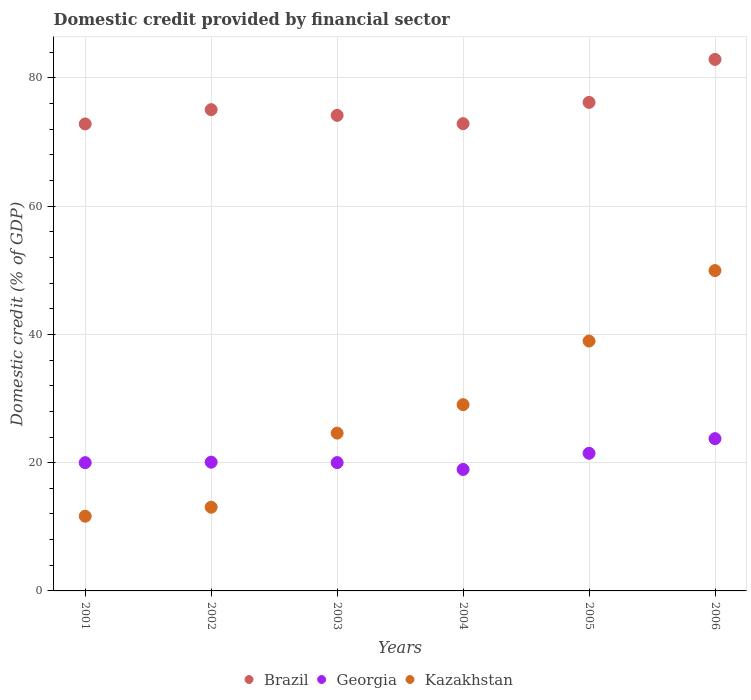How many different coloured dotlines are there?
Your answer should be compact. 3. What is the domestic credit in Georgia in 2004?
Ensure brevity in your answer.  18.95. Across all years, what is the maximum domestic credit in Kazakhstan?
Provide a succinct answer. 49.96. Across all years, what is the minimum domestic credit in Brazil?
Ensure brevity in your answer.  72.83. In which year was the domestic credit in Georgia minimum?
Make the answer very short. 2004. What is the total domestic credit in Georgia in the graph?
Give a very brief answer. 124.26. What is the difference between the domestic credit in Georgia in 2004 and that in 2005?
Offer a terse response. -2.52. What is the difference between the domestic credit in Brazil in 2003 and the domestic credit in Georgia in 2005?
Provide a short and direct response. 52.71. What is the average domestic credit in Kazakhstan per year?
Give a very brief answer. 27.88. In the year 2004, what is the difference between the domestic credit in Kazakhstan and domestic credit in Brazil?
Offer a terse response. -43.82. What is the ratio of the domestic credit in Kazakhstan in 2003 to that in 2005?
Make the answer very short. 0.63. Is the domestic credit in Georgia in 2002 less than that in 2006?
Your answer should be very brief. Yes. Is the difference between the domestic credit in Kazakhstan in 2003 and 2004 greater than the difference between the domestic credit in Brazil in 2003 and 2004?
Ensure brevity in your answer.  No. What is the difference between the highest and the second highest domestic credit in Kazakhstan?
Your response must be concise. 10.99. What is the difference between the highest and the lowest domestic credit in Kazakhstan?
Your answer should be compact. 38.31. In how many years, is the domestic credit in Brazil greater than the average domestic credit in Brazil taken over all years?
Keep it short and to the point. 2. Does the domestic credit in Georgia monotonically increase over the years?
Offer a very short reply. No. Is the domestic credit in Georgia strictly less than the domestic credit in Brazil over the years?
Provide a succinct answer. Yes. How many dotlines are there?
Your answer should be compact. 3. How many years are there in the graph?
Your answer should be compact. 6. What is the difference between two consecutive major ticks on the Y-axis?
Ensure brevity in your answer.  20. Does the graph contain any zero values?
Ensure brevity in your answer.  No. Does the graph contain grids?
Keep it short and to the point. Yes. Where does the legend appear in the graph?
Offer a terse response. Bottom center. What is the title of the graph?
Offer a very short reply. Domestic credit provided by financial sector. What is the label or title of the Y-axis?
Ensure brevity in your answer.  Domestic credit (% of GDP). What is the Domestic credit (% of GDP) of Brazil in 2001?
Provide a short and direct response. 72.83. What is the Domestic credit (% of GDP) of Georgia in 2001?
Offer a terse response. 20. What is the Domestic credit (% of GDP) of Kazakhstan in 2001?
Your response must be concise. 11.65. What is the Domestic credit (% of GDP) in Brazil in 2002?
Make the answer very short. 75.06. What is the Domestic credit (% of GDP) in Georgia in 2002?
Make the answer very short. 20.08. What is the Domestic credit (% of GDP) in Kazakhstan in 2002?
Your answer should be compact. 13.06. What is the Domestic credit (% of GDP) of Brazil in 2003?
Keep it short and to the point. 74.17. What is the Domestic credit (% of GDP) of Georgia in 2003?
Offer a very short reply. 20.02. What is the Domestic credit (% of GDP) in Kazakhstan in 2003?
Provide a short and direct response. 24.61. What is the Domestic credit (% of GDP) in Brazil in 2004?
Keep it short and to the point. 72.87. What is the Domestic credit (% of GDP) in Georgia in 2004?
Give a very brief answer. 18.95. What is the Domestic credit (% of GDP) of Kazakhstan in 2004?
Make the answer very short. 29.05. What is the Domestic credit (% of GDP) in Brazil in 2005?
Provide a short and direct response. 76.19. What is the Domestic credit (% of GDP) in Georgia in 2005?
Keep it short and to the point. 21.47. What is the Domestic credit (% of GDP) in Kazakhstan in 2005?
Provide a short and direct response. 38.97. What is the Domestic credit (% of GDP) in Brazil in 2006?
Give a very brief answer. 82.9. What is the Domestic credit (% of GDP) of Georgia in 2006?
Ensure brevity in your answer.  23.75. What is the Domestic credit (% of GDP) in Kazakhstan in 2006?
Make the answer very short. 49.96. Across all years, what is the maximum Domestic credit (% of GDP) of Brazil?
Ensure brevity in your answer.  82.9. Across all years, what is the maximum Domestic credit (% of GDP) of Georgia?
Provide a short and direct response. 23.75. Across all years, what is the maximum Domestic credit (% of GDP) in Kazakhstan?
Keep it short and to the point. 49.96. Across all years, what is the minimum Domestic credit (% of GDP) of Brazil?
Offer a very short reply. 72.83. Across all years, what is the minimum Domestic credit (% of GDP) of Georgia?
Ensure brevity in your answer.  18.95. Across all years, what is the minimum Domestic credit (% of GDP) of Kazakhstan?
Your response must be concise. 11.65. What is the total Domestic credit (% of GDP) in Brazil in the graph?
Provide a succinct answer. 454.03. What is the total Domestic credit (% of GDP) of Georgia in the graph?
Give a very brief answer. 124.26. What is the total Domestic credit (% of GDP) in Kazakhstan in the graph?
Your answer should be compact. 167.3. What is the difference between the Domestic credit (% of GDP) of Brazil in 2001 and that in 2002?
Give a very brief answer. -2.23. What is the difference between the Domestic credit (% of GDP) in Georgia in 2001 and that in 2002?
Keep it short and to the point. -0.08. What is the difference between the Domestic credit (% of GDP) of Kazakhstan in 2001 and that in 2002?
Your answer should be very brief. -1.41. What is the difference between the Domestic credit (% of GDP) of Brazil in 2001 and that in 2003?
Offer a very short reply. -1.34. What is the difference between the Domestic credit (% of GDP) of Georgia in 2001 and that in 2003?
Make the answer very short. -0.01. What is the difference between the Domestic credit (% of GDP) of Kazakhstan in 2001 and that in 2003?
Keep it short and to the point. -12.96. What is the difference between the Domestic credit (% of GDP) of Brazil in 2001 and that in 2004?
Give a very brief answer. -0.04. What is the difference between the Domestic credit (% of GDP) in Georgia in 2001 and that in 2004?
Your answer should be very brief. 1.06. What is the difference between the Domestic credit (% of GDP) of Kazakhstan in 2001 and that in 2004?
Make the answer very short. -17.4. What is the difference between the Domestic credit (% of GDP) in Brazil in 2001 and that in 2005?
Your answer should be very brief. -3.36. What is the difference between the Domestic credit (% of GDP) in Georgia in 2001 and that in 2005?
Provide a short and direct response. -1.46. What is the difference between the Domestic credit (% of GDP) of Kazakhstan in 2001 and that in 2005?
Ensure brevity in your answer.  -27.32. What is the difference between the Domestic credit (% of GDP) of Brazil in 2001 and that in 2006?
Provide a succinct answer. -10.06. What is the difference between the Domestic credit (% of GDP) of Georgia in 2001 and that in 2006?
Keep it short and to the point. -3.75. What is the difference between the Domestic credit (% of GDP) of Kazakhstan in 2001 and that in 2006?
Make the answer very short. -38.31. What is the difference between the Domestic credit (% of GDP) of Brazil in 2002 and that in 2003?
Your answer should be very brief. 0.89. What is the difference between the Domestic credit (% of GDP) of Georgia in 2002 and that in 2003?
Give a very brief answer. 0.07. What is the difference between the Domestic credit (% of GDP) of Kazakhstan in 2002 and that in 2003?
Ensure brevity in your answer.  -11.56. What is the difference between the Domestic credit (% of GDP) of Brazil in 2002 and that in 2004?
Give a very brief answer. 2.19. What is the difference between the Domestic credit (% of GDP) of Georgia in 2002 and that in 2004?
Keep it short and to the point. 1.13. What is the difference between the Domestic credit (% of GDP) in Kazakhstan in 2002 and that in 2004?
Keep it short and to the point. -16. What is the difference between the Domestic credit (% of GDP) of Brazil in 2002 and that in 2005?
Offer a very short reply. -1.13. What is the difference between the Domestic credit (% of GDP) of Georgia in 2002 and that in 2005?
Offer a terse response. -1.39. What is the difference between the Domestic credit (% of GDP) of Kazakhstan in 2002 and that in 2005?
Your answer should be compact. -25.91. What is the difference between the Domestic credit (% of GDP) in Brazil in 2002 and that in 2006?
Your answer should be compact. -7.84. What is the difference between the Domestic credit (% of GDP) of Georgia in 2002 and that in 2006?
Ensure brevity in your answer.  -3.67. What is the difference between the Domestic credit (% of GDP) of Kazakhstan in 2002 and that in 2006?
Give a very brief answer. -36.91. What is the difference between the Domestic credit (% of GDP) of Brazil in 2003 and that in 2004?
Give a very brief answer. 1.3. What is the difference between the Domestic credit (% of GDP) in Georgia in 2003 and that in 2004?
Provide a short and direct response. 1.07. What is the difference between the Domestic credit (% of GDP) in Kazakhstan in 2003 and that in 2004?
Provide a short and direct response. -4.44. What is the difference between the Domestic credit (% of GDP) in Brazil in 2003 and that in 2005?
Keep it short and to the point. -2.02. What is the difference between the Domestic credit (% of GDP) of Georgia in 2003 and that in 2005?
Provide a short and direct response. -1.45. What is the difference between the Domestic credit (% of GDP) of Kazakhstan in 2003 and that in 2005?
Your answer should be compact. -14.36. What is the difference between the Domestic credit (% of GDP) of Brazil in 2003 and that in 2006?
Provide a succinct answer. -8.73. What is the difference between the Domestic credit (% of GDP) of Georgia in 2003 and that in 2006?
Your response must be concise. -3.73. What is the difference between the Domestic credit (% of GDP) in Kazakhstan in 2003 and that in 2006?
Offer a very short reply. -25.35. What is the difference between the Domestic credit (% of GDP) in Brazil in 2004 and that in 2005?
Offer a very short reply. -3.32. What is the difference between the Domestic credit (% of GDP) in Georgia in 2004 and that in 2005?
Offer a very short reply. -2.52. What is the difference between the Domestic credit (% of GDP) in Kazakhstan in 2004 and that in 2005?
Offer a very short reply. -9.92. What is the difference between the Domestic credit (% of GDP) of Brazil in 2004 and that in 2006?
Your answer should be very brief. -10.02. What is the difference between the Domestic credit (% of GDP) of Georgia in 2004 and that in 2006?
Give a very brief answer. -4.8. What is the difference between the Domestic credit (% of GDP) in Kazakhstan in 2004 and that in 2006?
Provide a succinct answer. -20.91. What is the difference between the Domestic credit (% of GDP) in Brazil in 2005 and that in 2006?
Give a very brief answer. -6.7. What is the difference between the Domestic credit (% of GDP) in Georgia in 2005 and that in 2006?
Provide a short and direct response. -2.28. What is the difference between the Domestic credit (% of GDP) of Kazakhstan in 2005 and that in 2006?
Provide a succinct answer. -10.99. What is the difference between the Domestic credit (% of GDP) in Brazil in 2001 and the Domestic credit (% of GDP) in Georgia in 2002?
Provide a short and direct response. 52.75. What is the difference between the Domestic credit (% of GDP) in Brazil in 2001 and the Domestic credit (% of GDP) in Kazakhstan in 2002?
Offer a terse response. 59.78. What is the difference between the Domestic credit (% of GDP) of Georgia in 2001 and the Domestic credit (% of GDP) of Kazakhstan in 2002?
Keep it short and to the point. 6.95. What is the difference between the Domestic credit (% of GDP) of Brazil in 2001 and the Domestic credit (% of GDP) of Georgia in 2003?
Make the answer very short. 52.82. What is the difference between the Domestic credit (% of GDP) in Brazil in 2001 and the Domestic credit (% of GDP) in Kazakhstan in 2003?
Your answer should be compact. 48.22. What is the difference between the Domestic credit (% of GDP) in Georgia in 2001 and the Domestic credit (% of GDP) in Kazakhstan in 2003?
Your answer should be compact. -4.61. What is the difference between the Domestic credit (% of GDP) of Brazil in 2001 and the Domestic credit (% of GDP) of Georgia in 2004?
Keep it short and to the point. 53.89. What is the difference between the Domestic credit (% of GDP) in Brazil in 2001 and the Domestic credit (% of GDP) in Kazakhstan in 2004?
Your answer should be compact. 43.78. What is the difference between the Domestic credit (% of GDP) of Georgia in 2001 and the Domestic credit (% of GDP) of Kazakhstan in 2004?
Provide a short and direct response. -9.05. What is the difference between the Domestic credit (% of GDP) in Brazil in 2001 and the Domestic credit (% of GDP) in Georgia in 2005?
Provide a short and direct response. 51.37. What is the difference between the Domestic credit (% of GDP) of Brazil in 2001 and the Domestic credit (% of GDP) of Kazakhstan in 2005?
Your answer should be compact. 33.86. What is the difference between the Domestic credit (% of GDP) in Georgia in 2001 and the Domestic credit (% of GDP) in Kazakhstan in 2005?
Provide a short and direct response. -18.97. What is the difference between the Domestic credit (% of GDP) in Brazil in 2001 and the Domestic credit (% of GDP) in Georgia in 2006?
Offer a very short reply. 49.09. What is the difference between the Domestic credit (% of GDP) of Brazil in 2001 and the Domestic credit (% of GDP) of Kazakhstan in 2006?
Provide a short and direct response. 22.87. What is the difference between the Domestic credit (% of GDP) of Georgia in 2001 and the Domestic credit (% of GDP) of Kazakhstan in 2006?
Your response must be concise. -29.96. What is the difference between the Domestic credit (% of GDP) of Brazil in 2002 and the Domestic credit (% of GDP) of Georgia in 2003?
Give a very brief answer. 55.05. What is the difference between the Domestic credit (% of GDP) of Brazil in 2002 and the Domestic credit (% of GDP) of Kazakhstan in 2003?
Offer a terse response. 50.45. What is the difference between the Domestic credit (% of GDP) of Georgia in 2002 and the Domestic credit (% of GDP) of Kazakhstan in 2003?
Your answer should be compact. -4.53. What is the difference between the Domestic credit (% of GDP) of Brazil in 2002 and the Domestic credit (% of GDP) of Georgia in 2004?
Your response must be concise. 56.11. What is the difference between the Domestic credit (% of GDP) of Brazil in 2002 and the Domestic credit (% of GDP) of Kazakhstan in 2004?
Your answer should be compact. 46.01. What is the difference between the Domestic credit (% of GDP) of Georgia in 2002 and the Domestic credit (% of GDP) of Kazakhstan in 2004?
Ensure brevity in your answer.  -8.97. What is the difference between the Domestic credit (% of GDP) of Brazil in 2002 and the Domestic credit (% of GDP) of Georgia in 2005?
Your response must be concise. 53.6. What is the difference between the Domestic credit (% of GDP) of Brazil in 2002 and the Domestic credit (% of GDP) of Kazakhstan in 2005?
Make the answer very short. 36.09. What is the difference between the Domestic credit (% of GDP) of Georgia in 2002 and the Domestic credit (% of GDP) of Kazakhstan in 2005?
Your answer should be very brief. -18.89. What is the difference between the Domestic credit (% of GDP) of Brazil in 2002 and the Domestic credit (% of GDP) of Georgia in 2006?
Offer a very short reply. 51.31. What is the difference between the Domestic credit (% of GDP) of Brazil in 2002 and the Domestic credit (% of GDP) of Kazakhstan in 2006?
Keep it short and to the point. 25.1. What is the difference between the Domestic credit (% of GDP) of Georgia in 2002 and the Domestic credit (% of GDP) of Kazakhstan in 2006?
Ensure brevity in your answer.  -29.88. What is the difference between the Domestic credit (% of GDP) of Brazil in 2003 and the Domestic credit (% of GDP) of Georgia in 2004?
Provide a succinct answer. 55.22. What is the difference between the Domestic credit (% of GDP) of Brazil in 2003 and the Domestic credit (% of GDP) of Kazakhstan in 2004?
Your answer should be very brief. 45.12. What is the difference between the Domestic credit (% of GDP) of Georgia in 2003 and the Domestic credit (% of GDP) of Kazakhstan in 2004?
Offer a terse response. -9.04. What is the difference between the Domestic credit (% of GDP) in Brazil in 2003 and the Domestic credit (% of GDP) in Georgia in 2005?
Make the answer very short. 52.7. What is the difference between the Domestic credit (% of GDP) of Brazil in 2003 and the Domestic credit (% of GDP) of Kazakhstan in 2005?
Offer a very short reply. 35.2. What is the difference between the Domestic credit (% of GDP) in Georgia in 2003 and the Domestic credit (% of GDP) in Kazakhstan in 2005?
Give a very brief answer. -18.95. What is the difference between the Domestic credit (% of GDP) in Brazil in 2003 and the Domestic credit (% of GDP) in Georgia in 2006?
Provide a succinct answer. 50.42. What is the difference between the Domestic credit (% of GDP) of Brazil in 2003 and the Domestic credit (% of GDP) of Kazakhstan in 2006?
Make the answer very short. 24.21. What is the difference between the Domestic credit (% of GDP) in Georgia in 2003 and the Domestic credit (% of GDP) in Kazakhstan in 2006?
Your answer should be very brief. -29.95. What is the difference between the Domestic credit (% of GDP) of Brazil in 2004 and the Domestic credit (% of GDP) of Georgia in 2005?
Provide a short and direct response. 51.41. What is the difference between the Domestic credit (% of GDP) of Brazil in 2004 and the Domestic credit (% of GDP) of Kazakhstan in 2005?
Your answer should be compact. 33.9. What is the difference between the Domestic credit (% of GDP) in Georgia in 2004 and the Domestic credit (% of GDP) in Kazakhstan in 2005?
Provide a succinct answer. -20.02. What is the difference between the Domestic credit (% of GDP) in Brazil in 2004 and the Domestic credit (% of GDP) in Georgia in 2006?
Your answer should be very brief. 49.12. What is the difference between the Domestic credit (% of GDP) of Brazil in 2004 and the Domestic credit (% of GDP) of Kazakhstan in 2006?
Give a very brief answer. 22.91. What is the difference between the Domestic credit (% of GDP) of Georgia in 2004 and the Domestic credit (% of GDP) of Kazakhstan in 2006?
Your answer should be very brief. -31.02. What is the difference between the Domestic credit (% of GDP) in Brazil in 2005 and the Domestic credit (% of GDP) in Georgia in 2006?
Give a very brief answer. 52.45. What is the difference between the Domestic credit (% of GDP) in Brazil in 2005 and the Domestic credit (% of GDP) in Kazakhstan in 2006?
Make the answer very short. 26.23. What is the difference between the Domestic credit (% of GDP) of Georgia in 2005 and the Domestic credit (% of GDP) of Kazakhstan in 2006?
Your answer should be very brief. -28.5. What is the average Domestic credit (% of GDP) of Brazil per year?
Offer a terse response. 75.67. What is the average Domestic credit (% of GDP) of Georgia per year?
Your answer should be very brief. 20.71. What is the average Domestic credit (% of GDP) of Kazakhstan per year?
Your answer should be compact. 27.88. In the year 2001, what is the difference between the Domestic credit (% of GDP) of Brazil and Domestic credit (% of GDP) of Georgia?
Provide a short and direct response. 52.83. In the year 2001, what is the difference between the Domestic credit (% of GDP) in Brazil and Domestic credit (% of GDP) in Kazakhstan?
Make the answer very short. 61.18. In the year 2001, what is the difference between the Domestic credit (% of GDP) of Georgia and Domestic credit (% of GDP) of Kazakhstan?
Your response must be concise. 8.35. In the year 2002, what is the difference between the Domestic credit (% of GDP) of Brazil and Domestic credit (% of GDP) of Georgia?
Make the answer very short. 54.98. In the year 2002, what is the difference between the Domestic credit (% of GDP) of Brazil and Domestic credit (% of GDP) of Kazakhstan?
Provide a succinct answer. 62.01. In the year 2002, what is the difference between the Domestic credit (% of GDP) in Georgia and Domestic credit (% of GDP) in Kazakhstan?
Ensure brevity in your answer.  7.03. In the year 2003, what is the difference between the Domestic credit (% of GDP) in Brazil and Domestic credit (% of GDP) in Georgia?
Your answer should be very brief. 54.16. In the year 2003, what is the difference between the Domestic credit (% of GDP) of Brazil and Domestic credit (% of GDP) of Kazakhstan?
Your answer should be very brief. 49.56. In the year 2003, what is the difference between the Domestic credit (% of GDP) in Georgia and Domestic credit (% of GDP) in Kazakhstan?
Keep it short and to the point. -4.6. In the year 2004, what is the difference between the Domestic credit (% of GDP) in Brazil and Domestic credit (% of GDP) in Georgia?
Keep it short and to the point. 53.93. In the year 2004, what is the difference between the Domestic credit (% of GDP) of Brazil and Domestic credit (% of GDP) of Kazakhstan?
Your answer should be very brief. 43.82. In the year 2004, what is the difference between the Domestic credit (% of GDP) of Georgia and Domestic credit (% of GDP) of Kazakhstan?
Give a very brief answer. -10.1. In the year 2005, what is the difference between the Domestic credit (% of GDP) of Brazil and Domestic credit (% of GDP) of Georgia?
Your answer should be compact. 54.73. In the year 2005, what is the difference between the Domestic credit (% of GDP) of Brazil and Domestic credit (% of GDP) of Kazakhstan?
Give a very brief answer. 37.22. In the year 2005, what is the difference between the Domestic credit (% of GDP) of Georgia and Domestic credit (% of GDP) of Kazakhstan?
Keep it short and to the point. -17.5. In the year 2006, what is the difference between the Domestic credit (% of GDP) in Brazil and Domestic credit (% of GDP) in Georgia?
Provide a succinct answer. 59.15. In the year 2006, what is the difference between the Domestic credit (% of GDP) of Brazil and Domestic credit (% of GDP) of Kazakhstan?
Offer a terse response. 32.93. In the year 2006, what is the difference between the Domestic credit (% of GDP) in Georgia and Domestic credit (% of GDP) in Kazakhstan?
Ensure brevity in your answer.  -26.22. What is the ratio of the Domestic credit (% of GDP) in Brazil in 2001 to that in 2002?
Offer a very short reply. 0.97. What is the ratio of the Domestic credit (% of GDP) of Georgia in 2001 to that in 2002?
Offer a terse response. 1. What is the ratio of the Domestic credit (% of GDP) in Kazakhstan in 2001 to that in 2002?
Offer a terse response. 0.89. What is the ratio of the Domestic credit (% of GDP) in Brazil in 2001 to that in 2003?
Your answer should be compact. 0.98. What is the ratio of the Domestic credit (% of GDP) of Kazakhstan in 2001 to that in 2003?
Your response must be concise. 0.47. What is the ratio of the Domestic credit (% of GDP) in Brazil in 2001 to that in 2004?
Offer a very short reply. 1. What is the ratio of the Domestic credit (% of GDP) of Georgia in 2001 to that in 2004?
Keep it short and to the point. 1.06. What is the ratio of the Domestic credit (% of GDP) in Kazakhstan in 2001 to that in 2004?
Offer a terse response. 0.4. What is the ratio of the Domestic credit (% of GDP) in Brazil in 2001 to that in 2005?
Your response must be concise. 0.96. What is the ratio of the Domestic credit (% of GDP) of Georgia in 2001 to that in 2005?
Provide a short and direct response. 0.93. What is the ratio of the Domestic credit (% of GDP) of Kazakhstan in 2001 to that in 2005?
Your answer should be compact. 0.3. What is the ratio of the Domestic credit (% of GDP) of Brazil in 2001 to that in 2006?
Offer a very short reply. 0.88. What is the ratio of the Domestic credit (% of GDP) of Georgia in 2001 to that in 2006?
Your answer should be compact. 0.84. What is the ratio of the Domestic credit (% of GDP) in Kazakhstan in 2001 to that in 2006?
Your response must be concise. 0.23. What is the ratio of the Domestic credit (% of GDP) of Brazil in 2002 to that in 2003?
Ensure brevity in your answer.  1.01. What is the ratio of the Domestic credit (% of GDP) of Kazakhstan in 2002 to that in 2003?
Your answer should be compact. 0.53. What is the ratio of the Domestic credit (% of GDP) of Georgia in 2002 to that in 2004?
Make the answer very short. 1.06. What is the ratio of the Domestic credit (% of GDP) in Kazakhstan in 2002 to that in 2004?
Provide a short and direct response. 0.45. What is the ratio of the Domestic credit (% of GDP) of Brazil in 2002 to that in 2005?
Your answer should be very brief. 0.99. What is the ratio of the Domestic credit (% of GDP) in Georgia in 2002 to that in 2005?
Ensure brevity in your answer.  0.94. What is the ratio of the Domestic credit (% of GDP) of Kazakhstan in 2002 to that in 2005?
Keep it short and to the point. 0.34. What is the ratio of the Domestic credit (% of GDP) in Brazil in 2002 to that in 2006?
Offer a very short reply. 0.91. What is the ratio of the Domestic credit (% of GDP) of Georgia in 2002 to that in 2006?
Provide a short and direct response. 0.85. What is the ratio of the Domestic credit (% of GDP) of Kazakhstan in 2002 to that in 2006?
Offer a terse response. 0.26. What is the ratio of the Domestic credit (% of GDP) in Brazil in 2003 to that in 2004?
Your answer should be very brief. 1.02. What is the ratio of the Domestic credit (% of GDP) of Georgia in 2003 to that in 2004?
Provide a short and direct response. 1.06. What is the ratio of the Domestic credit (% of GDP) in Kazakhstan in 2003 to that in 2004?
Make the answer very short. 0.85. What is the ratio of the Domestic credit (% of GDP) in Brazil in 2003 to that in 2005?
Provide a succinct answer. 0.97. What is the ratio of the Domestic credit (% of GDP) in Georgia in 2003 to that in 2005?
Give a very brief answer. 0.93. What is the ratio of the Domestic credit (% of GDP) in Kazakhstan in 2003 to that in 2005?
Provide a succinct answer. 0.63. What is the ratio of the Domestic credit (% of GDP) in Brazil in 2003 to that in 2006?
Keep it short and to the point. 0.89. What is the ratio of the Domestic credit (% of GDP) of Georgia in 2003 to that in 2006?
Ensure brevity in your answer.  0.84. What is the ratio of the Domestic credit (% of GDP) of Kazakhstan in 2003 to that in 2006?
Make the answer very short. 0.49. What is the ratio of the Domestic credit (% of GDP) of Brazil in 2004 to that in 2005?
Provide a short and direct response. 0.96. What is the ratio of the Domestic credit (% of GDP) in Georgia in 2004 to that in 2005?
Provide a short and direct response. 0.88. What is the ratio of the Domestic credit (% of GDP) of Kazakhstan in 2004 to that in 2005?
Provide a succinct answer. 0.75. What is the ratio of the Domestic credit (% of GDP) of Brazil in 2004 to that in 2006?
Your answer should be very brief. 0.88. What is the ratio of the Domestic credit (% of GDP) of Georgia in 2004 to that in 2006?
Your answer should be compact. 0.8. What is the ratio of the Domestic credit (% of GDP) of Kazakhstan in 2004 to that in 2006?
Offer a terse response. 0.58. What is the ratio of the Domestic credit (% of GDP) of Brazil in 2005 to that in 2006?
Offer a terse response. 0.92. What is the ratio of the Domestic credit (% of GDP) of Georgia in 2005 to that in 2006?
Make the answer very short. 0.9. What is the ratio of the Domestic credit (% of GDP) in Kazakhstan in 2005 to that in 2006?
Your answer should be compact. 0.78. What is the difference between the highest and the second highest Domestic credit (% of GDP) in Brazil?
Make the answer very short. 6.7. What is the difference between the highest and the second highest Domestic credit (% of GDP) of Georgia?
Offer a very short reply. 2.28. What is the difference between the highest and the second highest Domestic credit (% of GDP) in Kazakhstan?
Your response must be concise. 10.99. What is the difference between the highest and the lowest Domestic credit (% of GDP) in Brazil?
Make the answer very short. 10.06. What is the difference between the highest and the lowest Domestic credit (% of GDP) in Georgia?
Your response must be concise. 4.8. What is the difference between the highest and the lowest Domestic credit (% of GDP) in Kazakhstan?
Provide a succinct answer. 38.31. 